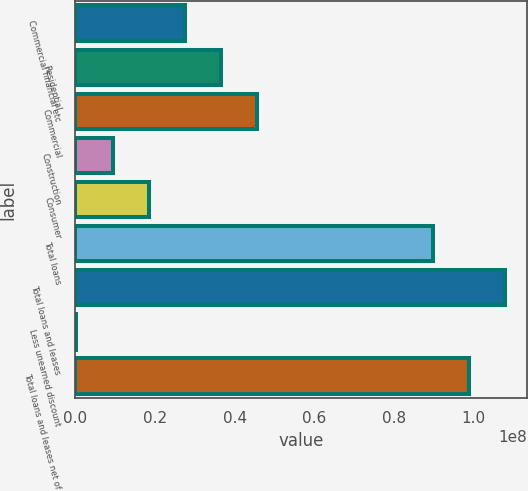<chart> <loc_0><loc_0><loc_500><loc_500><bar_chart><fcel>Commercial financial etc<fcel>Residential<fcel>Commercial<fcel>Construction<fcel>Consumer<fcel>Total loans<fcel>Total loans and leases<fcel>Less unearned discount<fcel>Total loans and leases net of<nl><fcel>2.75043e+07<fcel>3.65896e+07<fcel>4.5675e+07<fcel>9.3336e+06<fcel>1.84189e+07<fcel>8.96822e+07<fcel>1.07853e+08<fcel>248261<fcel>9.87675e+07<nl></chart> 